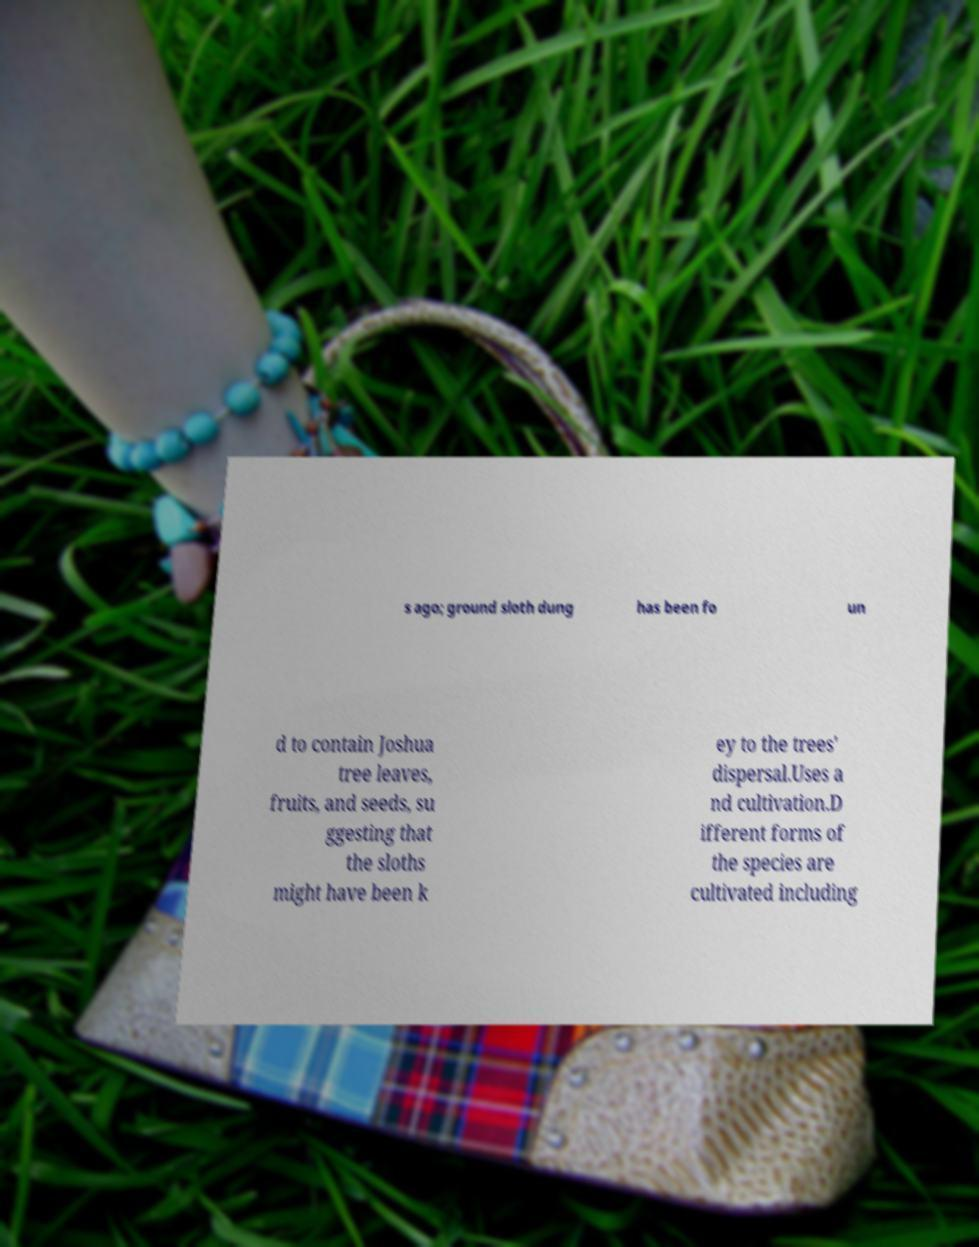I need the written content from this picture converted into text. Can you do that? s ago; ground sloth dung has been fo un d to contain Joshua tree leaves, fruits, and seeds, su ggesting that the sloths might have been k ey to the trees' dispersal.Uses a nd cultivation.D ifferent forms of the species are cultivated including 